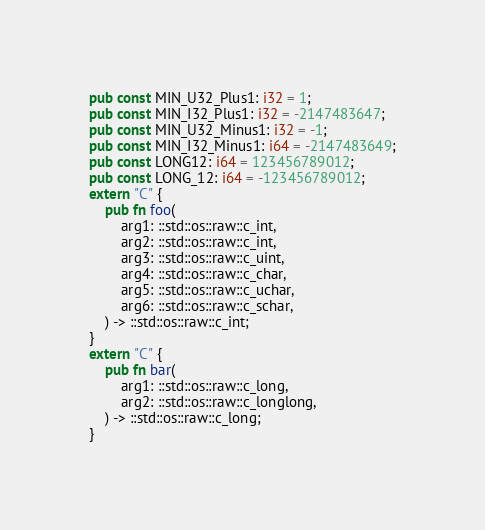<code> <loc_0><loc_0><loc_500><loc_500><_Rust_>pub const MIN_U32_Plus1: i32 = 1;
pub const MIN_I32_Plus1: i32 = -2147483647;
pub const MIN_U32_Minus1: i32 = -1;
pub const MIN_I32_Minus1: i64 = -2147483649;
pub const LONG12: i64 = 123456789012;
pub const LONG_12: i64 = -123456789012;
extern "C" {
    pub fn foo(
        arg1: ::std::os::raw::c_int,
        arg2: ::std::os::raw::c_int,
        arg3: ::std::os::raw::c_uint,
        arg4: ::std::os::raw::c_char,
        arg5: ::std::os::raw::c_uchar,
        arg6: ::std::os::raw::c_schar,
    ) -> ::std::os::raw::c_int;
}
extern "C" {
    pub fn bar(
        arg1: ::std::os::raw::c_long,
        arg2: ::std::os::raw::c_longlong,
    ) -> ::std::os::raw::c_long;
}
</code> 